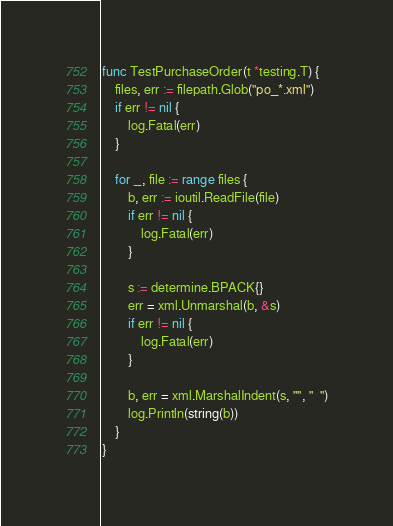<code> <loc_0><loc_0><loc_500><loc_500><_Go_>
func TestPurchaseOrder(t *testing.T) {
	files, err := filepath.Glob("po_*.xml")
	if err != nil {
		log.Fatal(err)
	}

	for _, file := range files {
		b, err := ioutil.ReadFile(file)
		if err != nil {
			log.Fatal(err)
		}

		s := determine.BPACK{}
		err = xml.Unmarshal(b, &s)
		if err != nil {
			log.Fatal(err)
		}

		b, err = xml.MarshalIndent(s, "", "  ")
		log.Println(string(b))
	}
}
</code> 